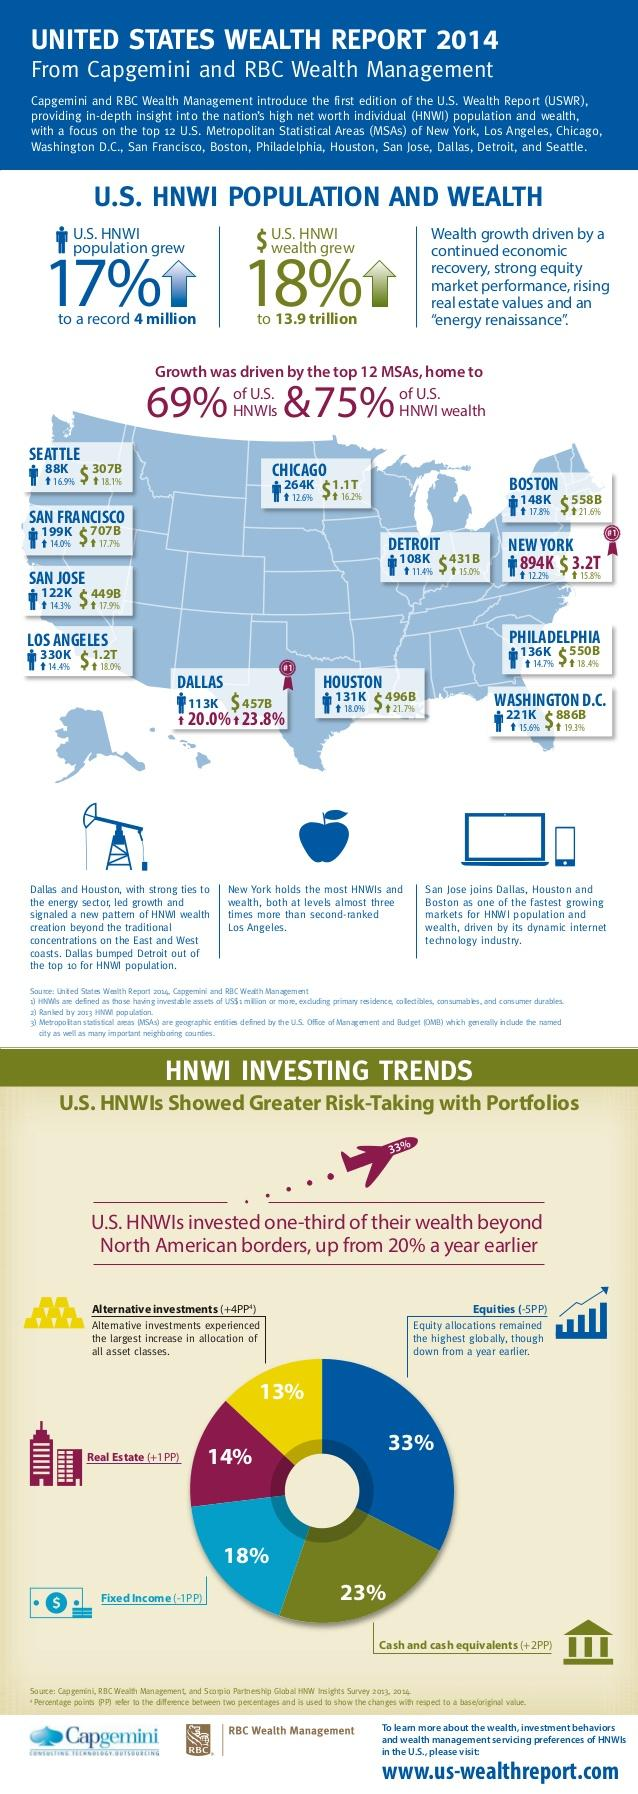Outline some significant characteristics in this image. The U.S. High Net Worth Individual of Wealth grew by 18% in the last year. 